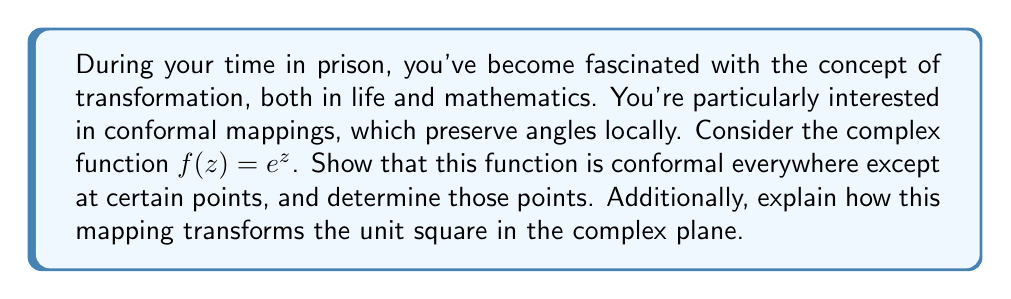Show me your answer to this math problem. To determine if $f(z) = e^z$ is conformal and find any exceptions, we need to examine its derivative.

1) A function is conformal at points where its derivative is non-zero. Let's find $f'(z)$:

   $f'(z) = \frac{d}{dz}(e^z) = e^z$

2) The function $f(z) = e^z$ is conformal at all points where $e^z \neq 0$. However, $e^z$ is never zero for any finite complex number $z$. Therefore, $f(z) = e^z$ is conformal everywhere in the complex plane.

3) To understand how this mapping transforms the unit square, let's consider a square with vertices at $0$, $1$, $1+i$, and $i$ in the complex plane.

4) The transformation of these points:
   - $f(0) = e^0 = 1$
   - $f(1) = e^1 \approx 2.718$
   - $f(i) = e^i = \cos(1) + i\sin(1) \approx 0.540 + 0.841i$
   - $f(1+i) = e^{1+i} = e \cdot (\cos(1) + i\sin(1)) \approx 1.468 + 2.287i$

5) The unit square is mapped to a region bounded by:
   - The arc of the unit circle from $1$ to $e^i$
   - The arc of the circle with radius $e$ from $e$ to $e^{1+i}$
   - Two logarithmic spirals connecting these arcs

This transformation preserves angles locally, demonstrating the conformal nature of the exponential function.
Answer: The function $f(z) = e^z$ is conformal everywhere in the complex plane. It transforms the unit square into a region bounded by circular arcs and logarithmic spirals, preserving angles locally. 